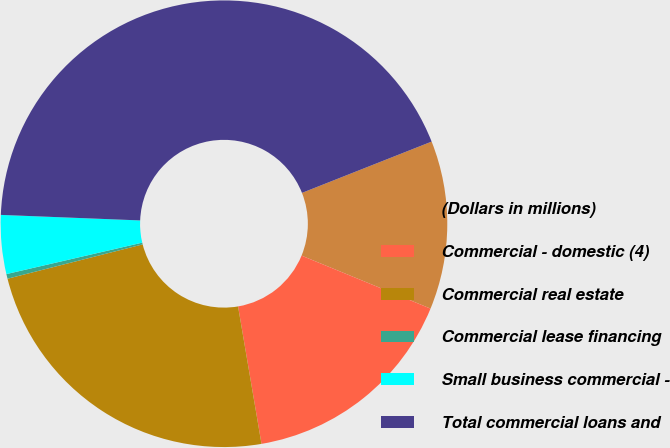Convert chart to OTSL. <chart><loc_0><loc_0><loc_500><loc_500><pie_chart><fcel>(Dollars in millions)<fcel>Commercial - domestic (4)<fcel>Commercial real estate<fcel>Commercial lease financing<fcel>Small business commercial -<fcel>Total commercial loans and<nl><fcel>12.2%<fcel>16.11%<fcel>23.73%<fcel>0.34%<fcel>4.25%<fcel>43.38%<nl></chart> 